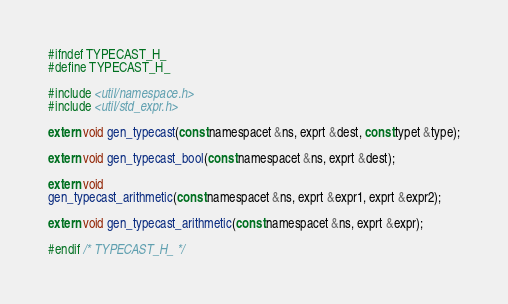<code> <loc_0><loc_0><loc_500><loc_500><_C_>#ifndef TYPECAST_H_
#define TYPECAST_H_

#include <util/namespace.h>
#include <util/std_expr.h>

extern void gen_typecast(const namespacet &ns, exprt &dest, const typet &type);

extern void gen_typecast_bool(const namespacet &ns, exprt &dest);

extern void
gen_typecast_arithmetic(const namespacet &ns, exprt &expr1, exprt &expr2);

extern void gen_typecast_arithmetic(const namespacet &ns, exprt &expr);

#endif /* TYPECAST_H_ */
</code> 